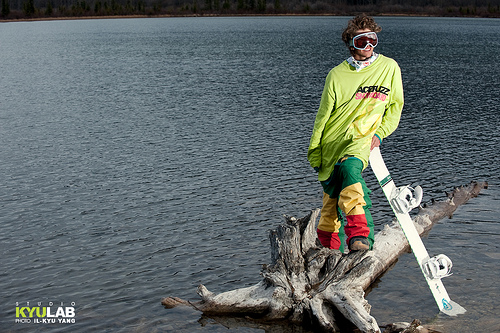Please extract the text content from this image. KYULAB KYU 